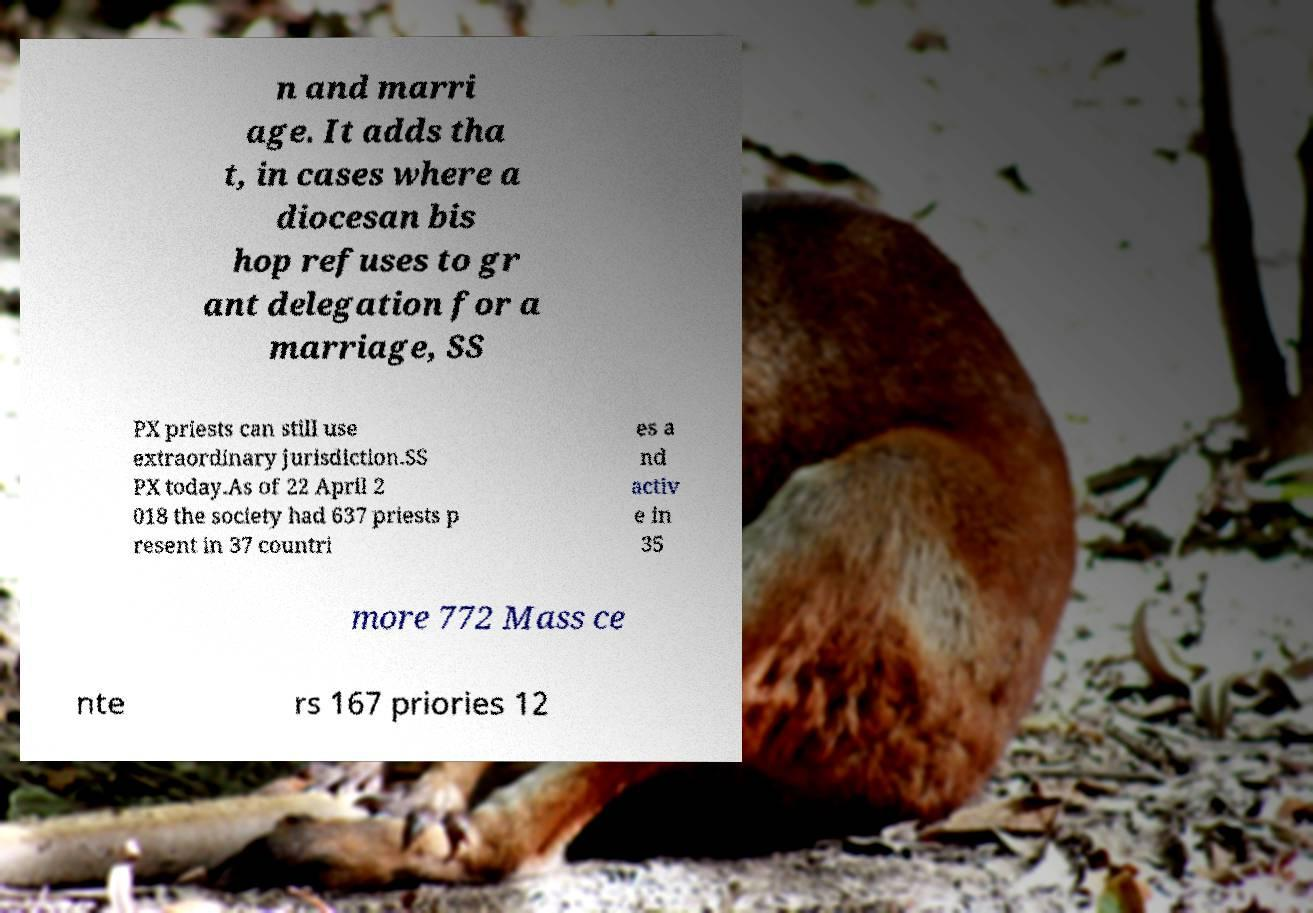Could you extract and type out the text from this image? n and marri age. It adds tha t, in cases where a diocesan bis hop refuses to gr ant delegation for a marriage, SS PX priests can still use extraordinary jurisdiction.SS PX today.As of 22 April 2 018 the society had 637 priests p resent in 37 countri es a nd activ e in 35 more 772 Mass ce nte rs 167 priories 12 